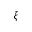<formula> <loc_0><loc_0><loc_500><loc_500>\xi</formula> 